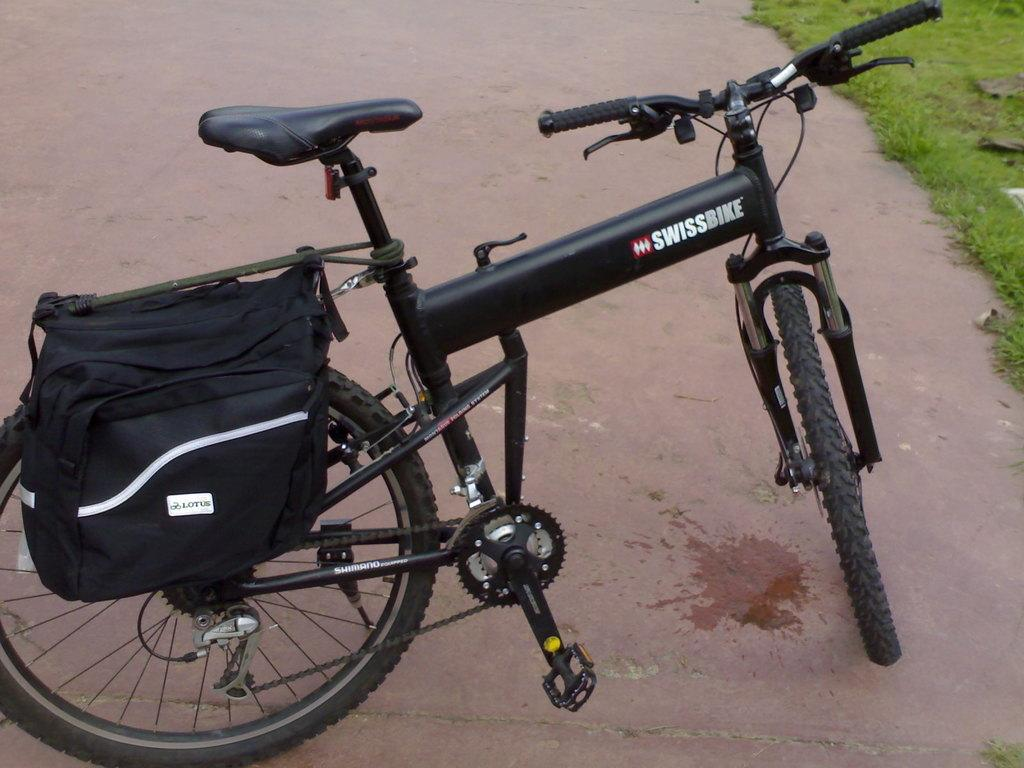What is the main object in the image? There is a bicycle with a bag in the image. Where is the bicycle located? The bicycle is parked on a path. What type of vegetation can be seen on the right side of the image? There is grass visible on the right side of the image. How does the bicycle aid in the digestion process in the image? The bicycle does not aid in the digestion process in the image; it is a mode of transportation and not related to digestion. Can you see any kittens playing near the bicycle in the image? There are no kittens present in the image. 